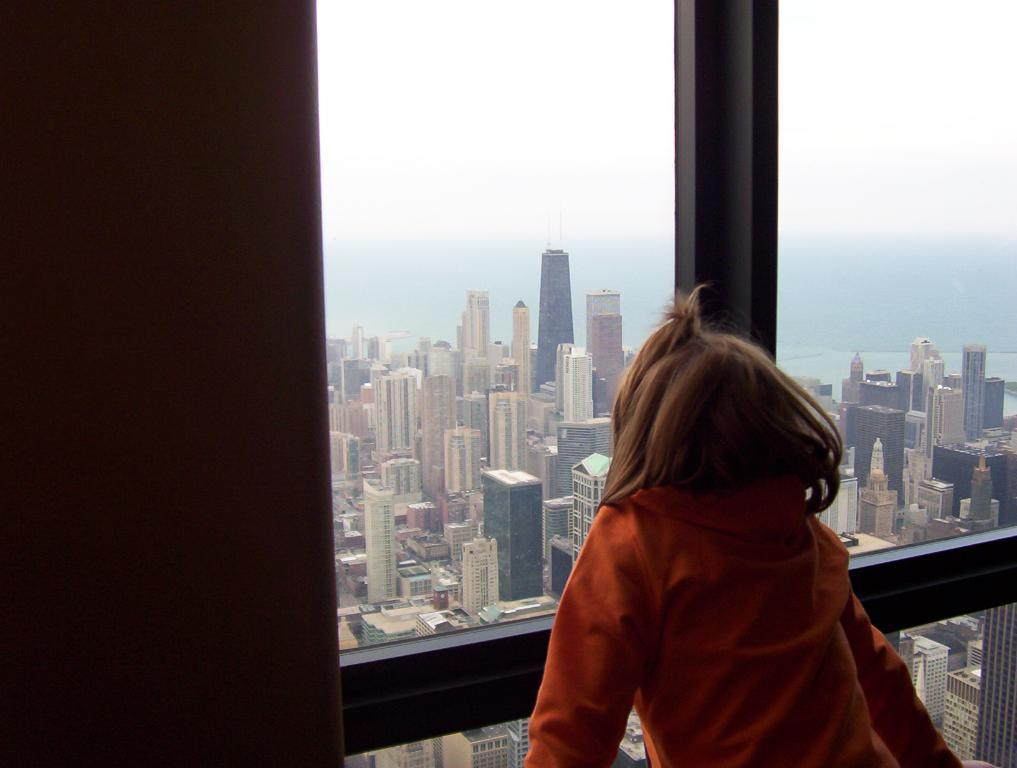What is the person in the image wearing? The person in the image is wearing an orange dress. What can be seen in the background of the image? There are buildings and a glass window visible in the background. What is the color of the sky in the image? The sky is blue and white in color. What type of memory is stored in the vessel in the image? There is no vessel or memory present in the image. What type of fuel is being used by the person in the image? There is no fuel or indication of any fuel-related activity in the image. 